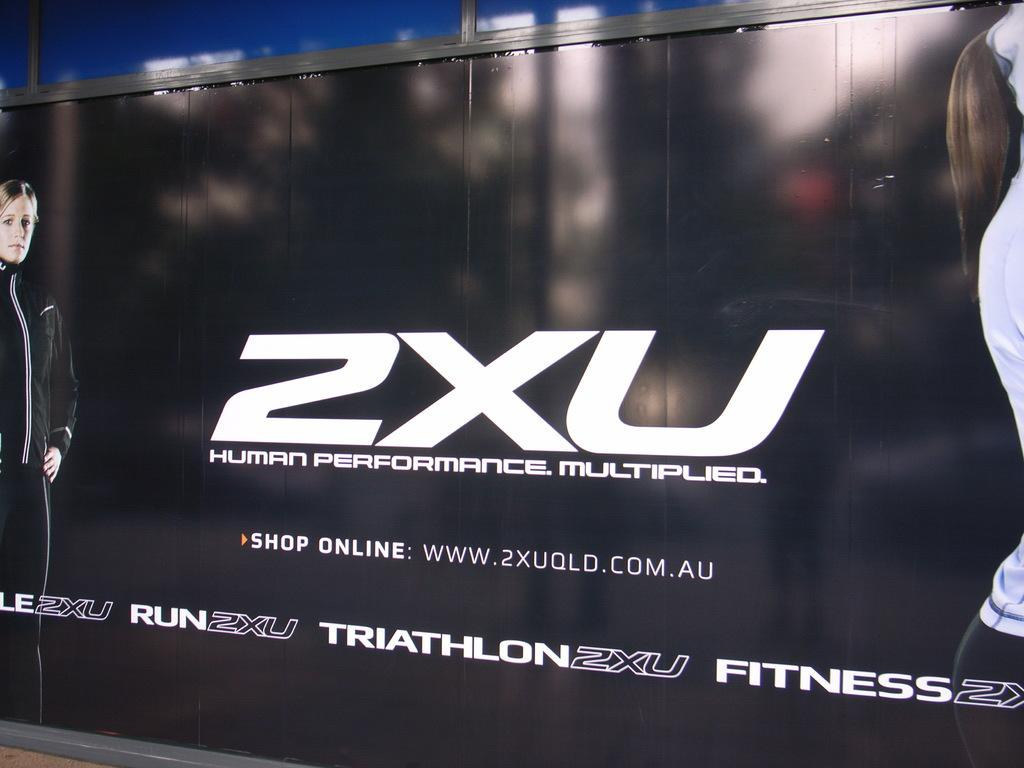<image>
Present a compact description of the photo's key features. A black advertisement screen with a man on the left side and with print saying 2XU Human Performance Multiplied. 